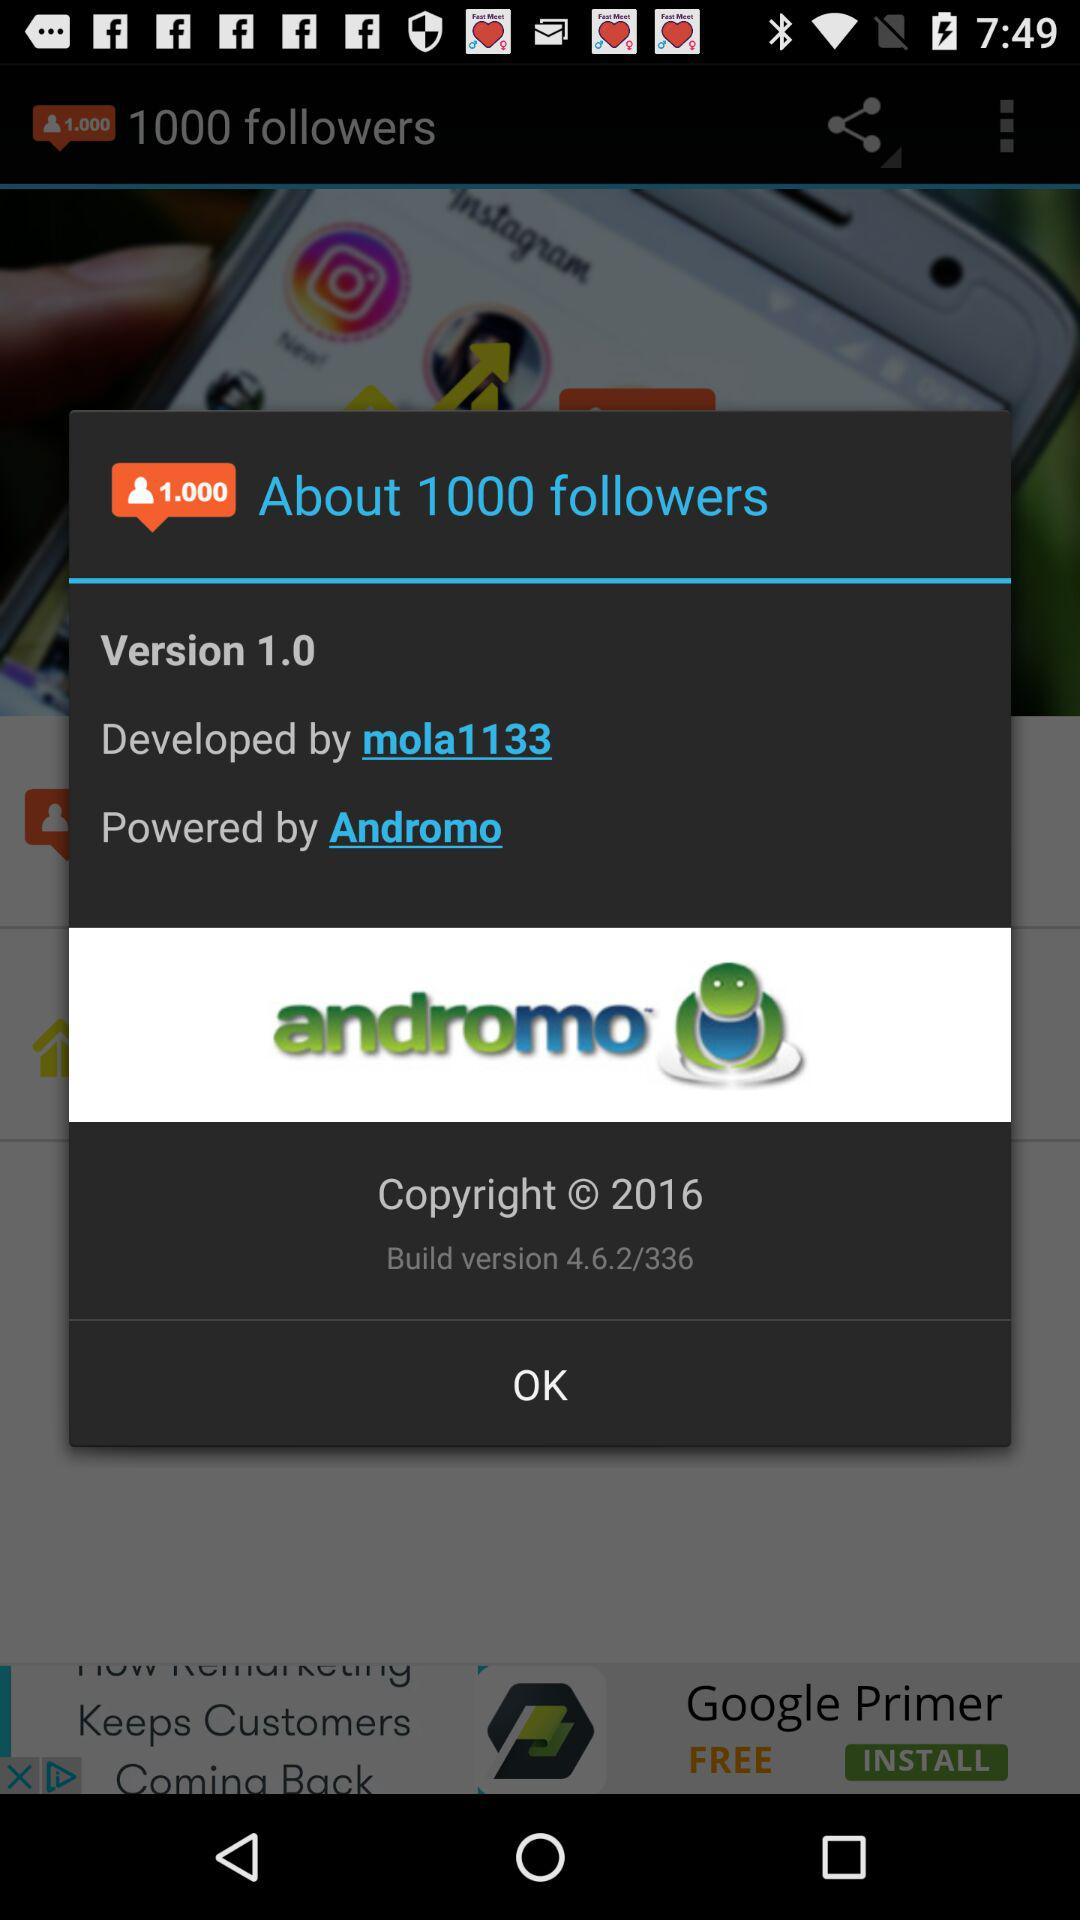By whom was it powered? It was powered by Andromo. 